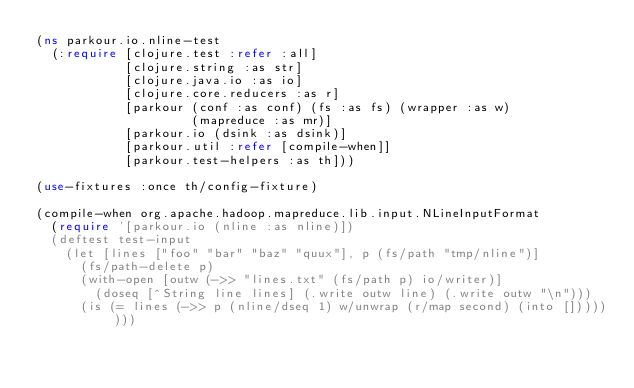Convert code to text. <code><loc_0><loc_0><loc_500><loc_500><_Clojure_>(ns parkour.io.nline-test
  (:require [clojure.test :refer :all]
            [clojure.string :as str]
            [clojure.java.io :as io]
            [clojure.core.reducers :as r]
            [parkour (conf :as conf) (fs :as fs) (wrapper :as w)
                     (mapreduce :as mr)]
            [parkour.io (dsink :as dsink)]
            [parkour.util :refer [compile-when]]
            [parkour.test-helpers :as th]))

(use-fixtures :once th/config-fixture)

(compile-when org.apache.hadoop.mapreduce.lib.input.NLineInputFormat
  (require '[parkour.io (nline :as nline)])
  (deftest test-input
    (let [lines ["foo" "bar" "baz" "quux"], p (fs/path "tmp/nline")]
      (fs/path-delete p)
      (with-open [outw (->> "lines.txt" (fs/path p) io/writer)]
        (doseq [^String line lines] (.write outw line) (.write outw "\n")))
      (is (= lines (->> p (nline/dseq 1) w/unwrap (r/map second) (into [])))))))
</code> 